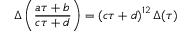<formula> <loc_0><loc_0><loc_500><loc_500>\Delta \left ( { \frac { a \tau + b } { c \tau + d } } \right ) = \left ( c \tau + d \right ) ^ { 1 2 } \Delta ( \tau )</formula> 